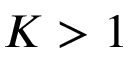Convert formula to latex. <formula><loc_0><loc_0><loc_500><loc_500>K > 1</formula> 